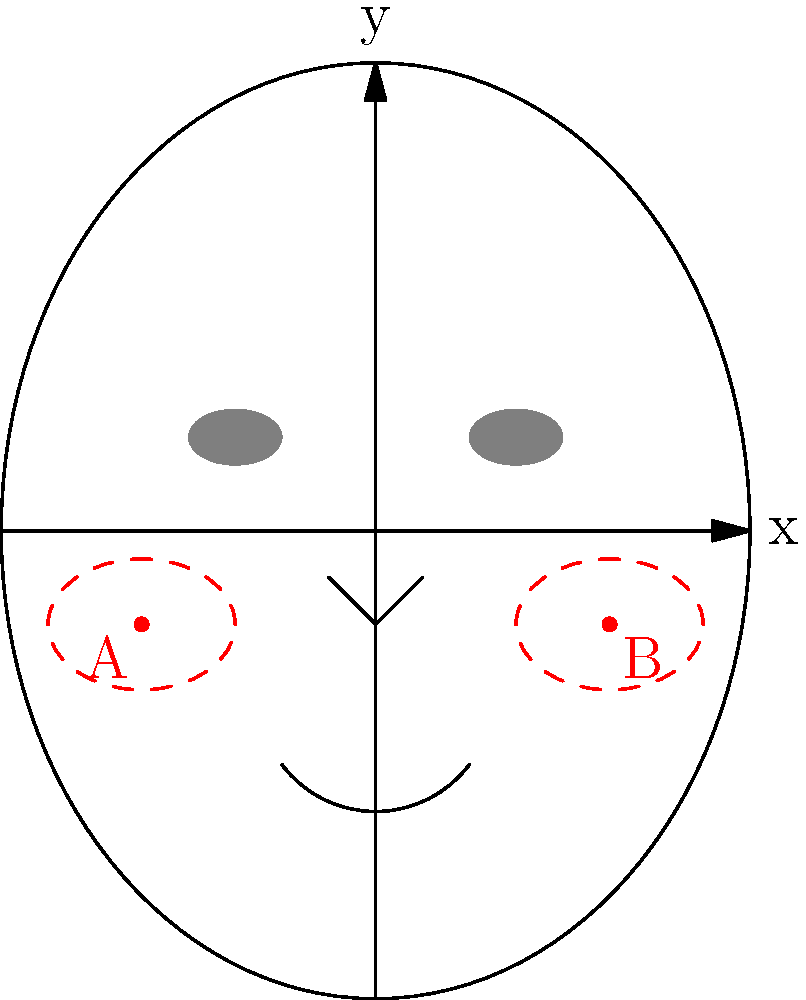In the facial grid coordinate system shown, the optimal blush placement is represented by the centers of the red dashed ellipses, labeled A and B. If point A is located at (-2.5, -1) and point B is symmetrical to A, what are the coordinates of point B? To determine the coordinates of point B, we need to follow these steps:

1. Identify the coordinates of point A: (-2.5, -1)

2. Recognize that point B is symmetrical to point A. In a facial grid system, symmetry typically occurs across the y-axis (vertical line through the center of the face).

3. To find the x-coordinate of point B:
   - The x-coordinate of B will be the opposite of A's x-coordinate.
   - A's x-coordinate is -2.5, so B's x-coordinate will be 2.5.

4. To find the y-coordinate of point B:
   - Since B is symmetrical to A, it will have the same y-coordinate.
   - A's y-coordinate is -1, so B's y-coordinate will also be -1.

5. Combine the x and y coordinates for point B: (2.5, -1)

Therefore, the coordinates of point B are (2.5, -1).
Answer: (2.5, -1) 